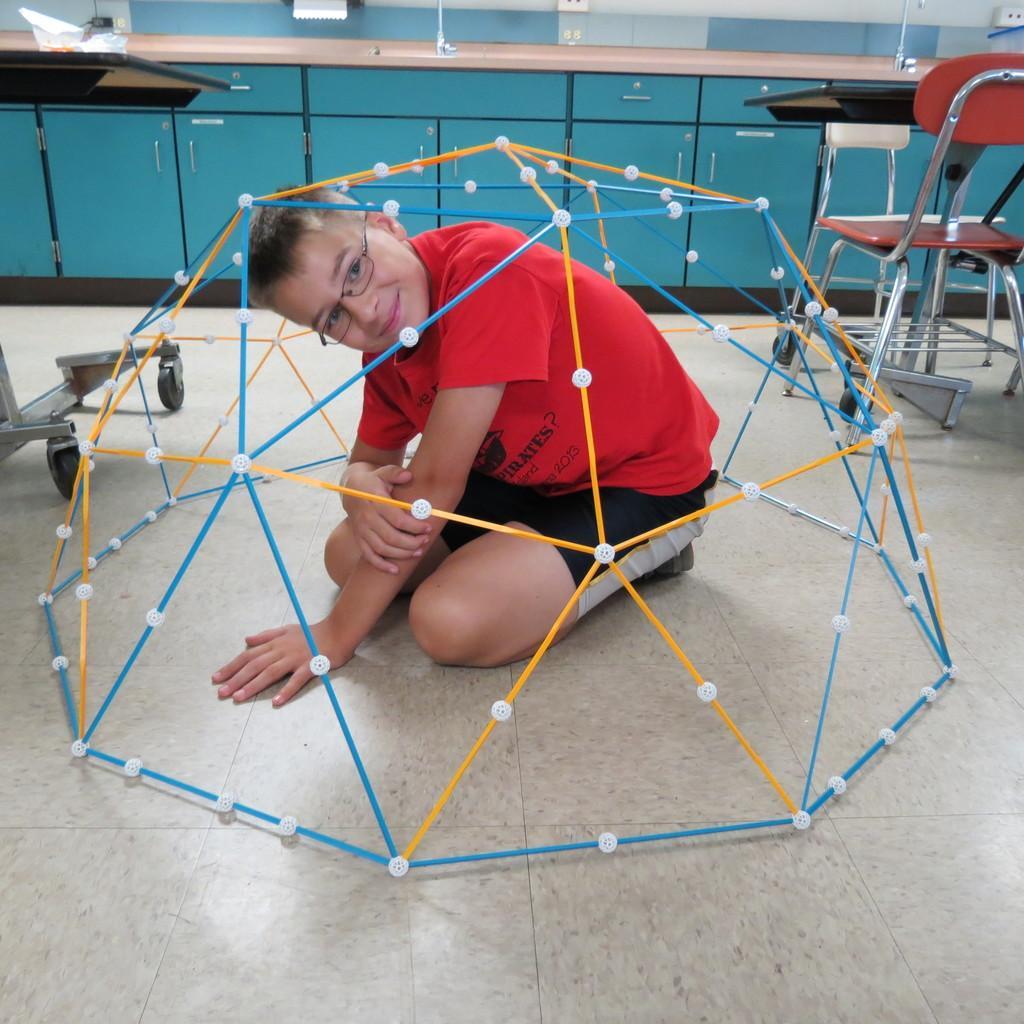Describe this image in one or two sentences. In this image, we can see a person wearing T-shirt and shorts is sitting inside an object. We can also see the floor. We can also see a chair and some tables. We can also see the cupboards. 